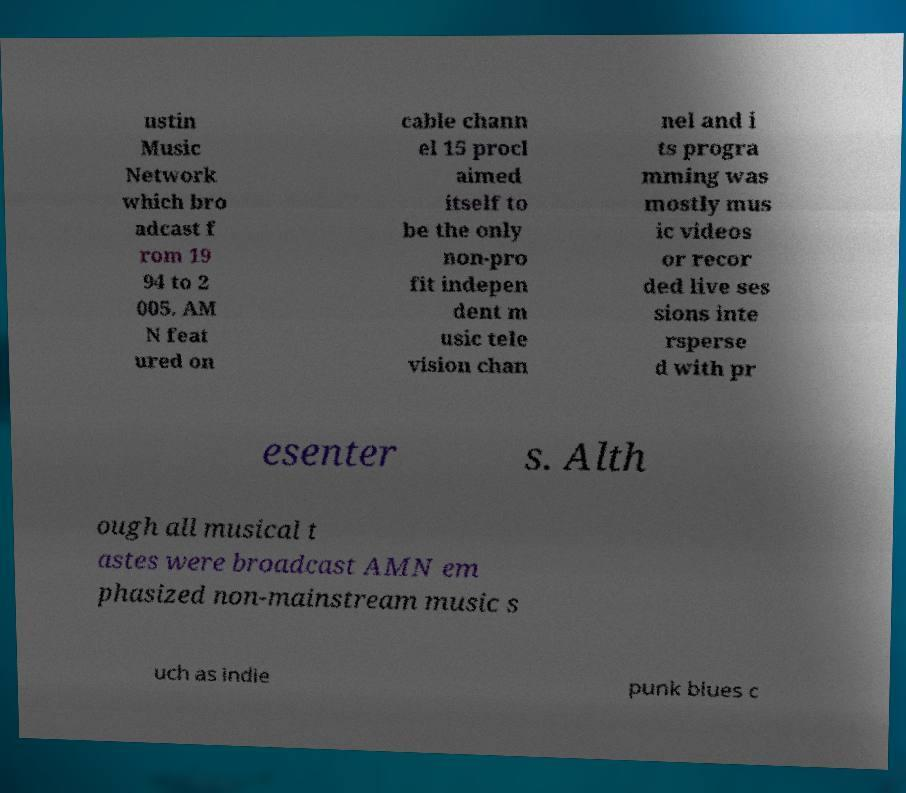There's text embedded in this image that I need extracted. Can you transcribe it verbatim? ustin Music Network which bro adcast f rom 19 94 to 2 005. AM N feat ured on cable chann el 15 procl aimed itself to be the only non-pro fit indepen dent m usic tele vision chan nel and i ts progra mming was mostly mus ic videos or recor ded live ses sions inte rsperse d with pr esenter s. Alth ough all musical t astes were broadcast AMN em phasized non-mainstream music s uch as indie punk blues c 